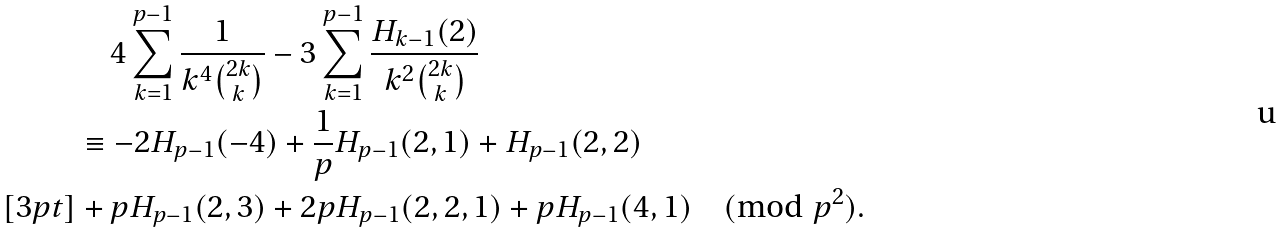Convert formula to latex. <formula><loc_0><loc_0><loc_500><loc_500>& \quad 4 \sum _ { k = 1 } ^ { p - 1 } \frac { 1 } { k ^ { 4 } \binom { 2 k } { k } } - 3 \sum _ { k = 1 } ^ { p - 1 } \frac { H _ { k - 1 } ( 2 ) } { k ^ { 2 } \binom { 2 k } { k } } \\ & \equiv - 2 H _ { p - 1 } ( - 4 ) + \frac { 1 } { p } H _ { p - 1 } ( 2 , 1 ) + H _ { p - 1 } ( 2 , 2 ) \\ [ 3 p t ] & + p H _ { p - 1 } ( 2 , 3 ) + 2 p H _ { p - 1 } ( 2 , 2 , 1 ) + p H _ { p - 1 } ( 4 , 1 ) \pmod { p ^ { 2 } } .</formula> 